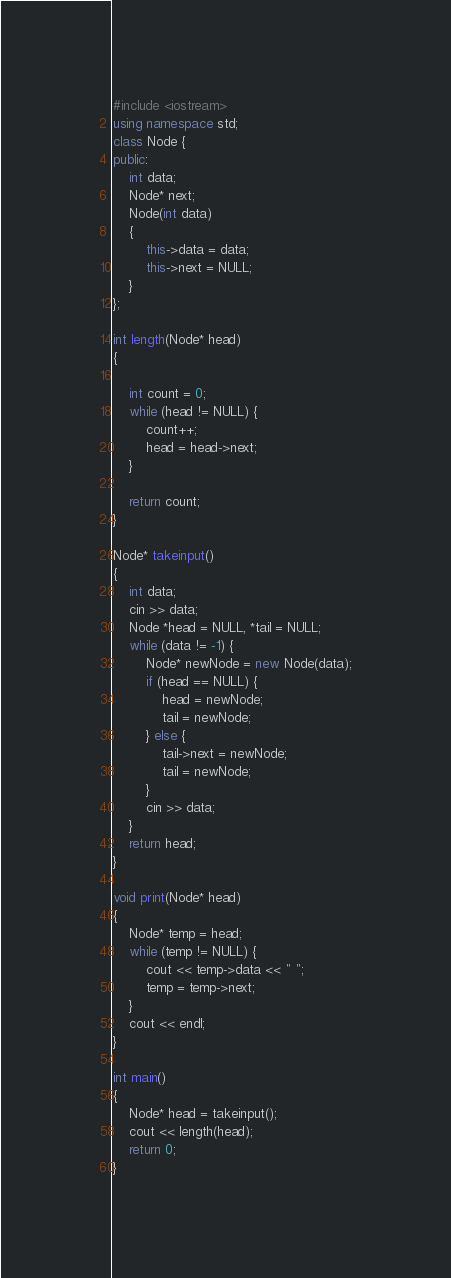<code> <loc_0><loc_0><loc_500><loc_500><_C++_>#include <iostream>
using namespace std;
class Node {
public:
    int data;
    Node* next;
    Node(int data)
    {
        this->data = data;
        this->next = NULL;
    }
};

int length(Node* head)
{

    int count = 0;
    while (head != NULL) {
        count++;
        head = head->next;
    }

    return count;
}

Node* takeinput()
{
    int data;
    cin >> data;
    Node *head = NULL, *tail = NULL;
    while (data != -1) {
        Node* newNode = new Node(data);
        if (head == NULL) {
            head = newNode;
            tail = newNode;
        } else {
            tail->next = newNode;
            tail = newNode;
        }
        cin >> data;
    }
    return head;
}

void print(Node* head)
{
    Node* temp = head;
    while (temp != NULL) {
        cout << temp->data << " ";
        temp = temp->next;
    }
    cout << endl;
}

int main()
{
    Node* head = takeinput();
    cout << length(head);
    return 0;
}
</code> 